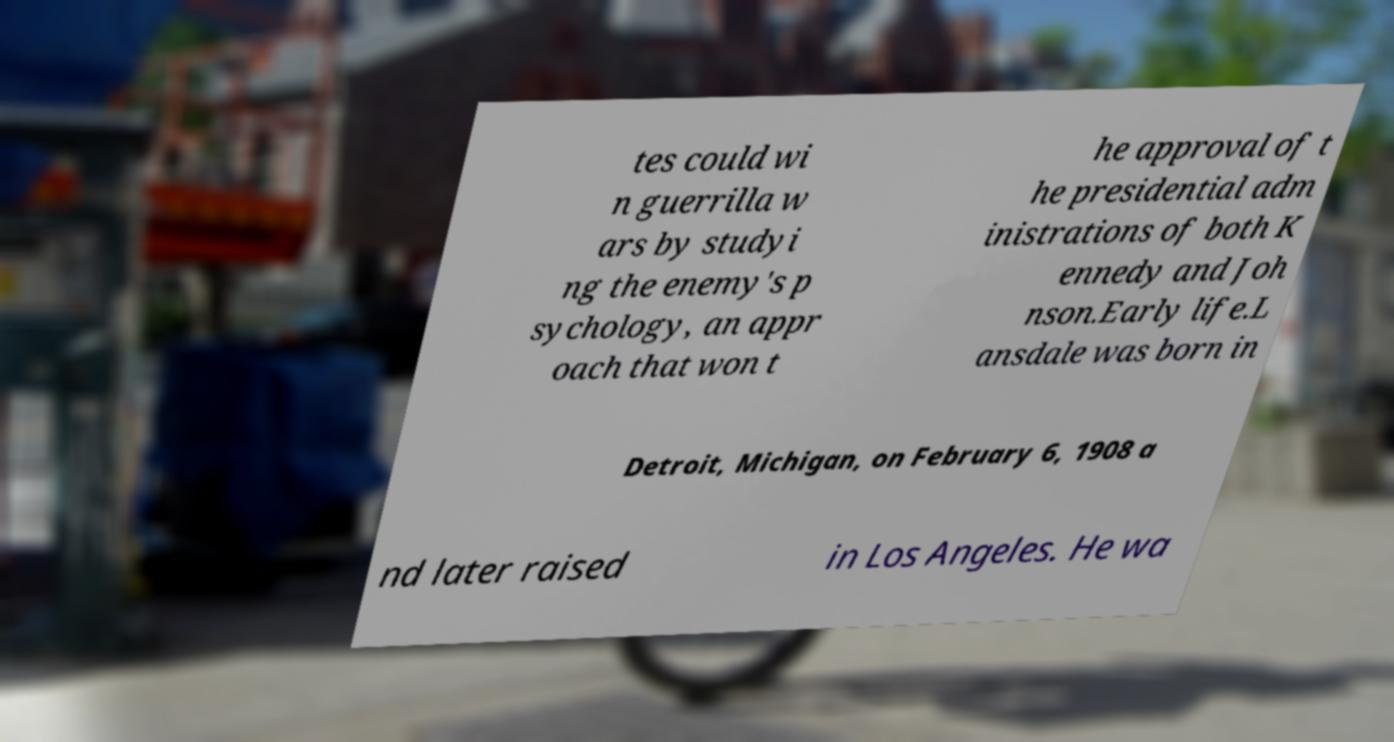Please read and relay the text visible in this image. What does it say? tes could wi n guerrilla w ars by studyi ng the enemy's p sychology, an appr oach that won t he approval of t he presidential adm inistrations of both K ennedy and Joh nson.Early life.L ansdale was born in Detroit, Michigan, on February 6, 1908 a nd later raised in Los Angeles. He wa 